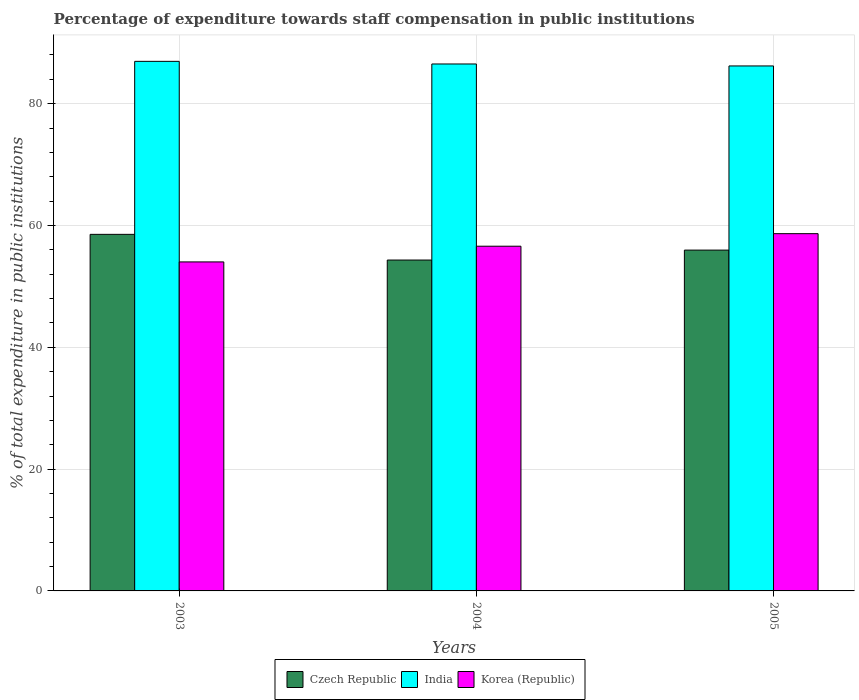How many different coloured bars are there?
Your response must be concise. 3. How many groups of bars are there?
Make the answer very short. 3. Are the number of bars per tick equal to the number of legend labels?
Keep it short and to the point. Yes. What is the label of the 3rd group of bars from the left?
Provide a succinct answer. 2005. What is the percentage of expenditure towards staff compensation in India in 2003?
Keep it short and to the point. 86.95. Across all years, what is the maximum percentage of expenditure towards staff compensation in Korea (Republic)?
Offer a very short reply. 58.66. Across all years, what is the minimum percentage of expenditure towards staff compensation in India?
Keep it short and to the point. 86.2. In which year was the percentage of expenditure towards staff compensation in Korea (Republic) minimum?
Offer a terse response. 2003. What is the total percentage of expenditure towards staff compensation in India in the graph?
Make the answer very short. 259.68. What is the difference between the percentage of expenditure towards staff compensation in Czech Republic in 2003 and that in 2005?
Keep it short and to the point. 2.59. What is the difference between the percentage of expenditure towards staff compensation in Czech Republic in 2005 and the percentage of expenditure towards staff compensation in India in 2004?
Give a very brief answer. -30.56. What is the average percentage of expenditure towards staff compensation in Czech Republic per year?
Your response must be concise. 56.28. In the year 2004, what is the difference between the percentage of expenditure towards staff compensation in Korea (Republic) and percentage of expenditure towards staff compensation in India?
Your answer should be very brief. -29.92. In how many years, is the percentage of expenditure towards staff compensation in India greater than 60 %?
Give a very brief answer. 3. What is the ratio of the percentage of expenditure towards staff compensation in India in 2004 to that in 2005?
Give a very brief answer. 1. What is the difference between the highest and the second highest percentage of expenditure towards staff compensation in Czech Republic?
Ensure brevity in your answer.  2.59. What is the difference between the highest and the lowest percentage of expenditure towards staff compensation in India?
Ensure brevity in your answer.  0.75. In how many years, is the percentage of expenditure towards staff compensation in Korea (Republic) greater than the average percentage of expenditure towards staff compensation in Korea (Republic) taken over all years?
Offer a terse response. 2. Is the sum of the percentage of expenditure towards staff compensation in Czech Republic in 2003 and 2005 greater than the maximum percentage of expenditure towards staff compensation in Korea (Republic) across all years?
Provide a short and direct response. Yes. What does the 1st bar from the left in 2004 represents?
Offer a terse response. Czech Republic. What does the 3rd bar from the right in 2004 represents?
Your response must be concise. Czech Republic. How many bars are there?
Give a very brief answer. 9. Are all the bars in the graph horizontal?
Give a very brief answer. No. How many years are there in the graph?
Make the answer very short. 3. What is the difference between two consecutive major ticks on the Y-axis?
Make the answer very short. 20. Does the graph contain grids?
Provide a succinct answer. Yes. Where does the legend appear in the graph?
Ensure brevity in your answer.  Bottom center. How are the legend labels stacked?
Your answer should be compact. Horizontal. What is the title of the graph?
Your answer should be very brief. Percentage of expenditure towards staff compensation in public institutions. Does "Maldives" appear as one of the legend labels in the graph?
Your response must be concise. No. What is the label or title of the X-axis?
Your answer should be very brief. Years. What is the label or title of the Y-axis?
Ensure brevity in your answer.  % of total expenditure in public institutions. What is the % of total expenditure in public institutions in Czech Republic in 2003?
Offer a very short reply. 58.55. What is the % of total expenditure in public institutions in India in 2003?
Keep it short and to the point. 86.95. What is the % of total expenditure in public institutions of Korea (Republic) in 2003?
Offer a very short reply. 54.02. What is the % of total expenditure in public institutions in Czech Republic in 2004?
Your answer should be very brief. 54.33. What is the % of total expenditure in public institutions of India in 2004?
Your answer should be very brief. 86.52. What is the % of total expenditure in public institutions in Korea (Republic) in 2004?
Offer a terse response. 56.6. What is the % of total expenditure in public institutions of Czech Republic in 2005?
Provide a short and direct response. 55.96. What is the % of total expenditure in public institutions in India in 2005?
Your answer should be very brief. 86.2. What is the % of total expenditure in public institutions of Korea (Republic) in 2005?
Provide a succinct answer. 58.66. Across all years, what is the maximum % of total expenditure in public institutions in Czech Republic?
Provide a short and direct response. 58.55. Across all years, what is the maximum % of total expenditure in public institutions of India?
Offer a very short reply. 86.95. Across all years, what is the maximum % of total expenditure in public institutions in Korea (Republic)?
Offer a very short reply. 58.66. Across all years, what is the minimum % of total expenditure in public institutions in Czech Republic?
Give a very brief answer. 54.33. Across all years, what is the minimum % of total expenditure in public institutions of India?
Ensure brevity in your answer.  86.2. Across all years, what is the minimum % of total expenditure in public institutions in Korea (Republic)?
Your answer should be very brief. 54.02. What is the total % of total expenditure in public institutions of Czech Republic in the graph?
Provide a short and direct response. 168.84. What is the total % of total expenditure in public institutions of India in the graph?
Provide a succinct answer. 259.68. What is the total % of total expenditure in public institutions in Korea (Republic) in the graph?
Ensure brevity in your answer.  169.29. What is the difference between the % of total expenditure in public institutions in Czech Republic in 2003 and that in 2004?
Provide a succinct answer. 4.22. What is the difference between the % of total expenditure in public institutions in India in 2003 and that in 2004?
Keep it short and to the point. 0.43. What is the difference between the % of total expenditure in public institutions of Korea (Republic) in 2003 and that in 2004?
Offer a terse response. -2.58. What is the difference between the % of total expenditure in public institutions of Czech Republic in 2003 and that in 2005?
Offer a very short reply. 2.59. What is the difference between the % of total expenditure in public institutions of India in 2003 and that in 2005?
Provide a short and direct response. 0.75. What is the difference between the % of total expenditure in public institutions in Korea (Republic) in 2003 and that in 2005?
Offer a terse response. -4.64. What is the difference between the % of total expenditure in public institutions of Czech Republic in 2004 and that in 2005?
Provide a succinct answer. -1.63. What is the difference between the % of total expenditure in public institutions of India in 2004 and that in 2005?
Make the answer very short. 0.32. What is the difference between the % of total expenditure in public institutions in Korea (Republic) in 2004 and that in 2005?
Offer a terse response. -2.06. What is the difference between the % of total expenditure in public institutions of Czech Republic in 2003 and the % of total expenditure in public institutions of India in 2004?
Your response must be concise. -27.98. What is the difference between the % of total expenditure in public institutions in Czech Republic in 2003 and the % of total expenditure in public institutions in Korea (Republic) in 2004?
Your response must be concise. 1.95. What is the difference between the % of total expenditure in public institutions of India in 2003 and the % of total expenditure in public institutions of Korea (Republic) in 2004?
Your answer should be compact. 30.35. What is the difference between the % of total expenditure in public institutions in Czech Republic in 2003 and the % of total expenditure in public institutions in India in 2005?
Your answer should be very brief. -27.65. What is the difference between the % of total expenditure in public institutions of Czech Republic in 2003 and the % of total expenditure in public institutions of Korea (Republic) in 2005?
Provide a short and direct response. -0.11. What is the difference between the % of total expenditure in public institutions of India in 2003 and the % of total expenditure in public institutions of Korea (Republic) in 2005?
Your answer should be compact. 28.29. What is the difference between the % of total expenditure in public institutions of Czech Republic in 2004 and the % of total expenditure in public institutions of India in 2005?
Your response must be concise. -31.87. What is the difference between the % of total expenditure in public institutions in Czech Republic in 2004 and the % of total expenditure in public institutions in Korea (Republic) in 2005?
Give a very brief answer. -4.33. What is the difference between the % of total expenditure in public institutions of India in 2004 and the % of total expenditure in public institutions of Korea (Republic) in 2005?
Give a very brief answer. 27.86. What is the average % of total expenditure in public institutions of Czech Republic per year?
Your answer should be compact. 56.28. What is the average % of total expenditure in public institutions of India per year?
Your answer should be very brief. 86.56. What is the average % of total expenditure in public institutions of Korea (Republic) per year?
Ensure brevity in your answer.  56.43. In the year 2003, what is the difference between the % of total expenditure in public institutions in Czech Republic and % of total expenditure in public institutions in India?
Offer a terse response. -28.41. In the year 2003, what is the difference between the % of total expenditure in public institutions in Czech Republic and % of total expenditure in public institutions in Korea (Republic)?
Keep it short and to the point. 4.52. In the year 2003, what is the difference between the % of total expenditure in public institutions of India and % of total expenditure in public institutions of Korea (Republic)?
Make the answer very short. 32.93. In the year 2004, what is the difference between the % of total expenditure in public institutions of Czech Republic and % of total expenditure in public institutions of India?
Ensure brevity in your answer.  -32.19. In the year 2004, what is the difference between the % of total expenditure in public institutions in Czech Republic and % of total expenditure in public institutions in Korea (Republic)?
Offer a terse response. -2.27. In the year 2004, what is the difference between the % of total expenditure in public institutions of India and % of total expenditure in public institutions of Korea (Republic)?
Your answer should be very brief. 29.92. In the year 2005, what is the difference between the % of total expenditure in public institutions in Czech Republic and % of total expenditure in public institutions in India?
Offer a terse response. -30.24. In the year 2005, what is the difference between the % of total expenditure in public institutions of Czech Republic and % of total expenditure in public institutions of Korea (Republic)?
Give a very brief answer. -2.7. In the year 2005, what is the difference between the % of total expenditure in public institutions in India and % of total expenditure in public institutions in Korea (Republic)?
Keep it short and to the point. 27.54. What is the ratio of the % of total expenditure in public institutions of Czech Republic in 2003 to that in 2004?
Your response must be concise. 1.08. What is the ratio of the % of total expenditure in public institutions in Korea (Republic) in 2003 to that in 2004?
Offer a very short reply. 0.95. What is the ratio of the % of total expenditure in public institutions in Czech Republic in 2003 to that in 2005?
Offer a terse response. 1.05. What is the ratio of the % of total expenditure in public institutions in India in 2003 to that in 2005?
Your answer should be very brief. 1.01. What is the ratio of the % of total expenditure in public institutions of Korea (Republic) in 2003 to that in 2005?
Provide a short and direct response. 0.92. What is the ratio of the % of total expenditure in public institutions of Czech Republic in 2004 to that in 2005?
Keep it short and to the point. 0.97. What is the ratio of the % of total expenditure in public institutions in India in 2004 to that in 2005?
Your response must be concise. 1. What is the ratio of the % of total expenditure in public institutions in Korea (Republic) in 2004 to that in 2005?
Your answer should be compact. 0.96. What is the difference between the highest and the second highest % of total expenditure in public institutions in Czech Republic?
Your response must be concise. 2.59. What is the difference between the highest and the second highest % of total expenditure in public institutions of India?
Make the answer very short. 0.43. What is the difference between the highest and the second highest % of total expenditure in public institutions of Korea (Republic)?
Your response must be concise. 2.06. What is the difference between the highest and the lowest % of total expenditure in public institutions in Czech Republic?
Provide a short and direct response. 4.22. What is the difference between the highest and the lowest % of total expenditure in public institutions in India?
Your answer should be compact. 0.75. What is the difference between the highest and the lowest % of total expenditure in public institutions in Korea (Republic)?
Make the answer very short. 4.64. 